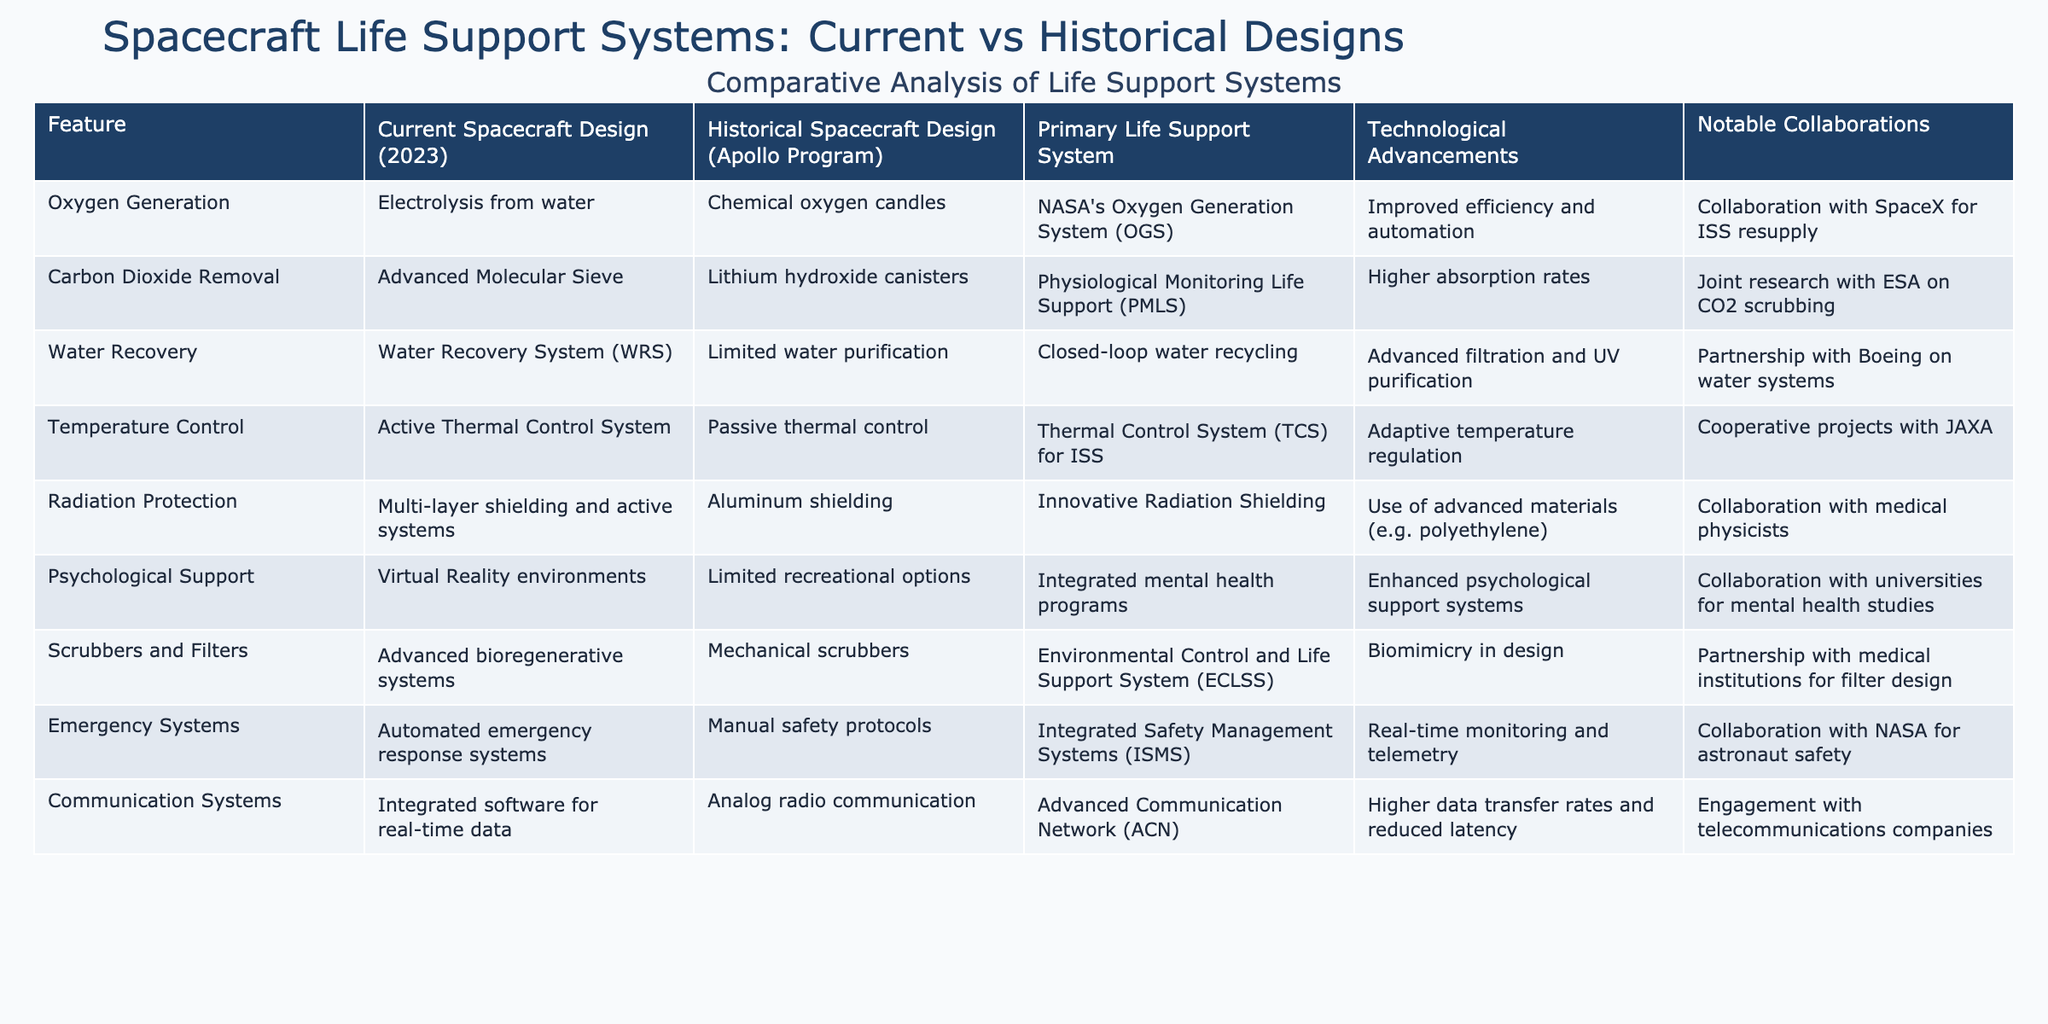What life support system is used for Oxygen Generation in current spacecraft? The table indicates that current spacecraft design uses "Electrolysis from water" for oxygen generation.
Answer: Electrolysis from water Which life support system has a higher absorption rate for Carbon Dioxide Removal? According to the data, the "Advanced Molecular Sieve" in current designs has a higher absorption rate compared to "Lithium hydroxide canisters" used in historical designs.
Answer: Current designs What is the main technological advancement for Water Recovery systems in current spacecraft? The table specifies that the Water Recovery System (WRS) in current designs features "Advanced filtration and UV purification" as its main technological advancement.
Answer: Advanced filtration and UV purification Is the Collaboration with SpaceX focused on Emergency Systems? The table states that the collaboration with SpaceX is related to ISS resupply and does not pertain to Emergency Systems.
Answer: No How do the temperature control systems of current spacecraft differ from historical systems? The current spacecraft uses an "Active Thermal Control System" while historical systems utilized "Passive thermal control," indicating a shift towards active management of temperature.
Answer: Active vs. Passive Control In what way does the psychological support in current spacecraft designs surpass historical designs? Current spacecraft designs include "Integrated mental health programs" and utilize "Virtual Reality environments," while historical designs had "Limited recreational options." This shows a significant improvement in support.
Answer: Integrated mental health programs Which spacecraft feature has innovative radiation shielding, and how does it compare to historical designs? Current spacecraft use "Multi-layer shielding and active systems" which represent innovative radiation shielding technologies compared to "Aluminum shielding" used in historical designs, indicating an advancement in protection.
Answer: Multi-layer shielding and active systems What are the primary life support systems identified in the current and historical spacecraft designs? The primary life support systems for current designs are detailed as "Oxygen Generation," "Carbon Dioxide Removal," "Water Recovery," and others, while historical designs list comparable systems like chemical oxygen candles and lithium hydroxide canisters, showing an evolution in technology.
Answer: Multiple systems How does the participation of medical physicists influence the radiation protection approach in current spacecraft? The table notes that current designs have "Innovative Radiation Shielding" developed through collaboration with medical physicists, suggesting that their expertise contributes to advancements in protective technologies.
Answer: Positive influence What is the overall trend in life support system technology from historical to current spacecraft designs? The overall trend indicates significant advancements in efficiency, automation, and integrated systems in current spacecraft compared to the simpler, manual, and limited capabilities of historical designs, showcasing progress in space mission technology.
Answer: Significant advancements 